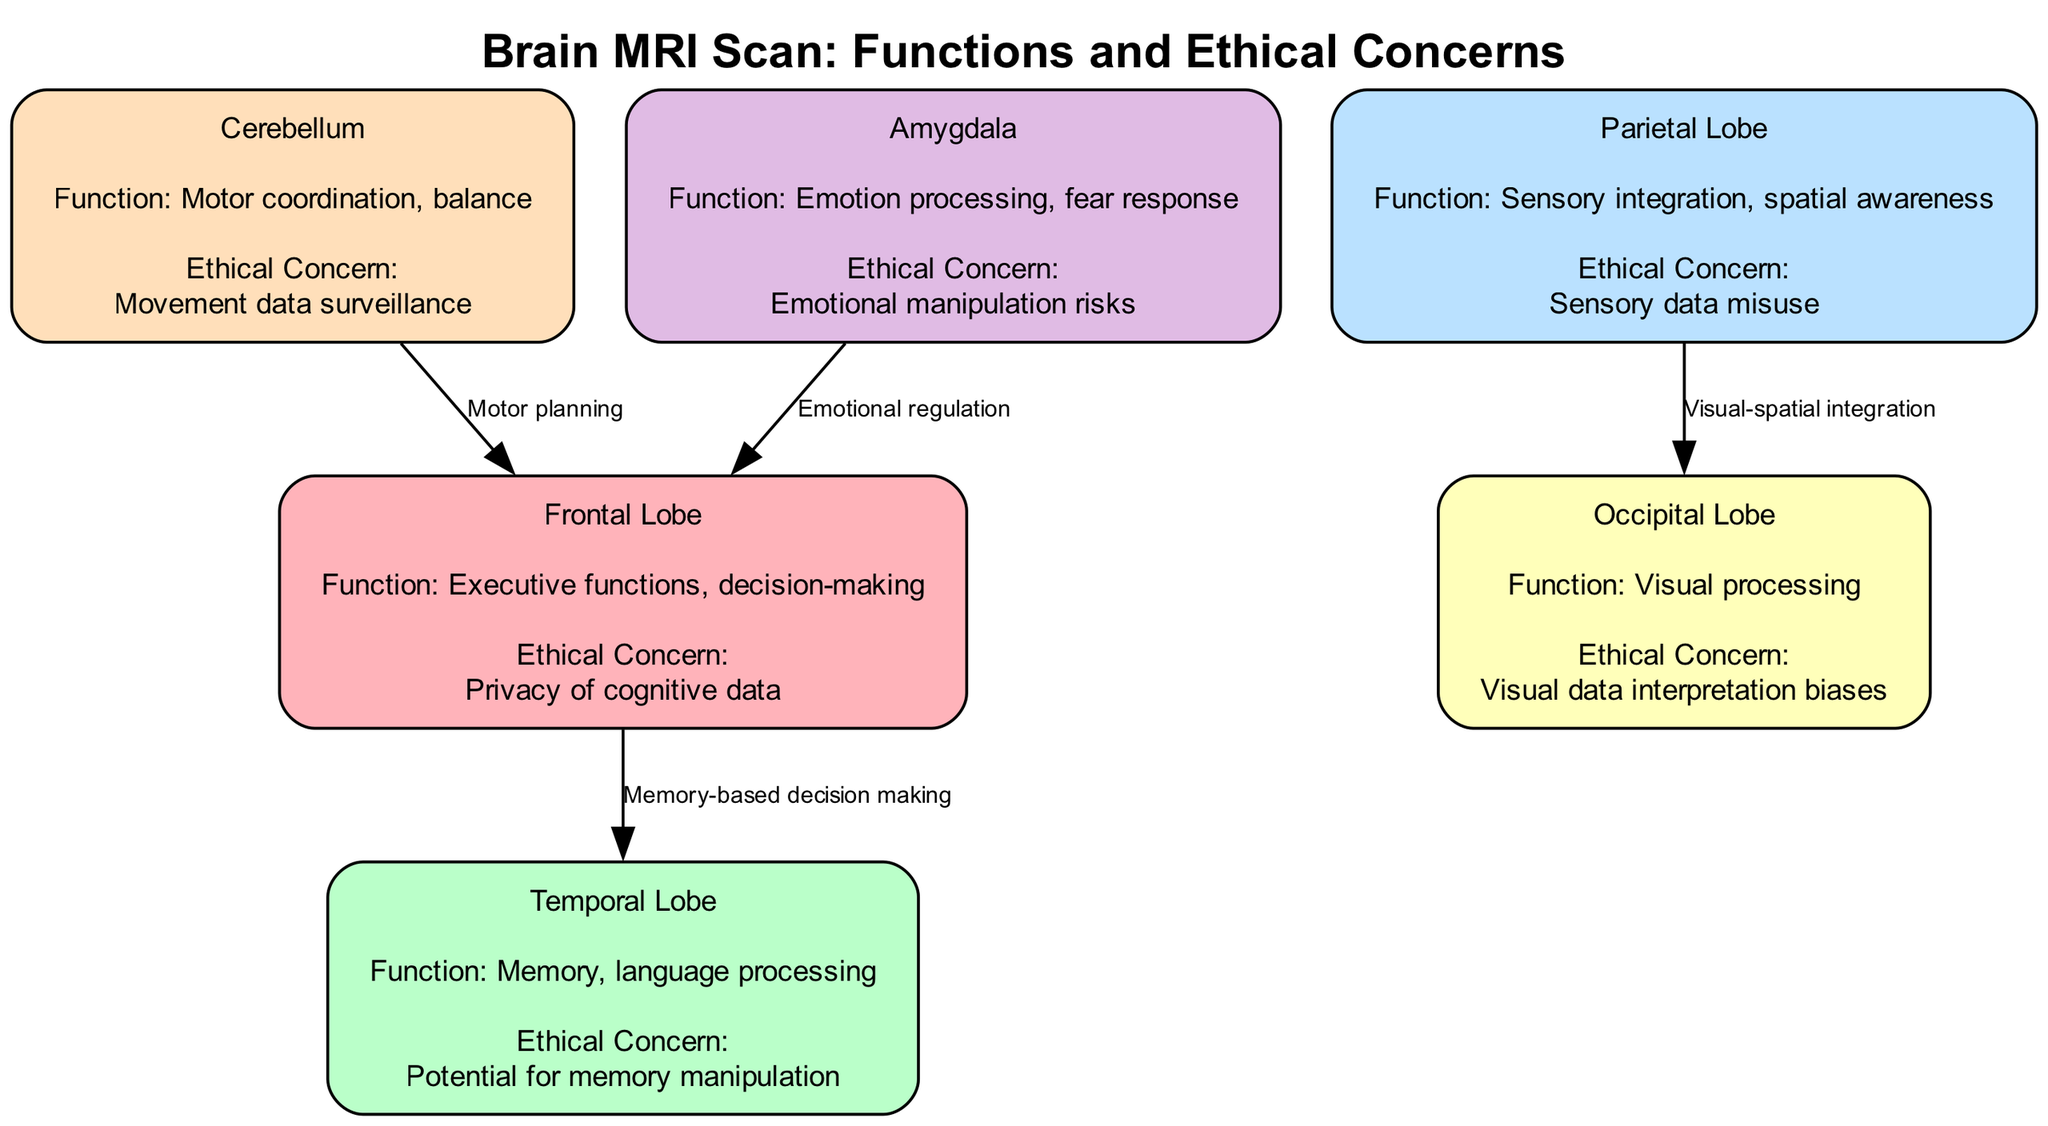What is the function of the occipital lobe? The occipital lobe is labeled for visual processing. This can be found directly under the "function" annotation for this node in the diagram.
Answer: Visual processing Which node is connected to the frontal lobe for emotional regulation? The diagram indicates that the amygdala has an edge leading to the frontal lobe, and it specifies the relationship as emotional regulation. Thus, the amygdala connects to the frontal lobe in this context.
Answer: Amygdala How many nodes are there in the diagram? Counting the nodes presented in the diagram data, there are six distinct nodes representing different brain regions. Therefore, the total is six.
Answer: 6 What ethical concern is associated with the temporal lobe? The ethical concern linked to the temporal lobe in the diagram is potential for memory manipulation, as noted in the annotation for this node.
Answer: Potential for memory manipulation What is the relationship labeled between the parietal lobe and occipital lobe? The diagram shows a directed edge from the parietal lobe to the occipital lobe, labeled as visual-spatial integration. This provides insight into how these regions interact in the context of sensory processing.
Answer: Visual-spatial integration What is the ethical concern related to sensory data as per the parietal lobe? In examining the parietal lobe node, the ethical concern pertains to sensory data misuse. This concern is clearly stated under the ethical annotations for this lobe.
Answer: Sensory data misuse Which brain region is responsible for executive functions and decision-making? The frontal lobe is specifically annotated in the diagram for conducting executive functions and decision-making. This provides a clear indication of its primary neurological role.
Answer: Frontal Lobe What potential risk is associated with the amygdala? The ethical concern related to the amygdala is emotional manipulation risks, as detailed in the ethical concern section of this node. This defines a potential ethical implication of studying this brain area.
Answer: Emotional manipulation risks 